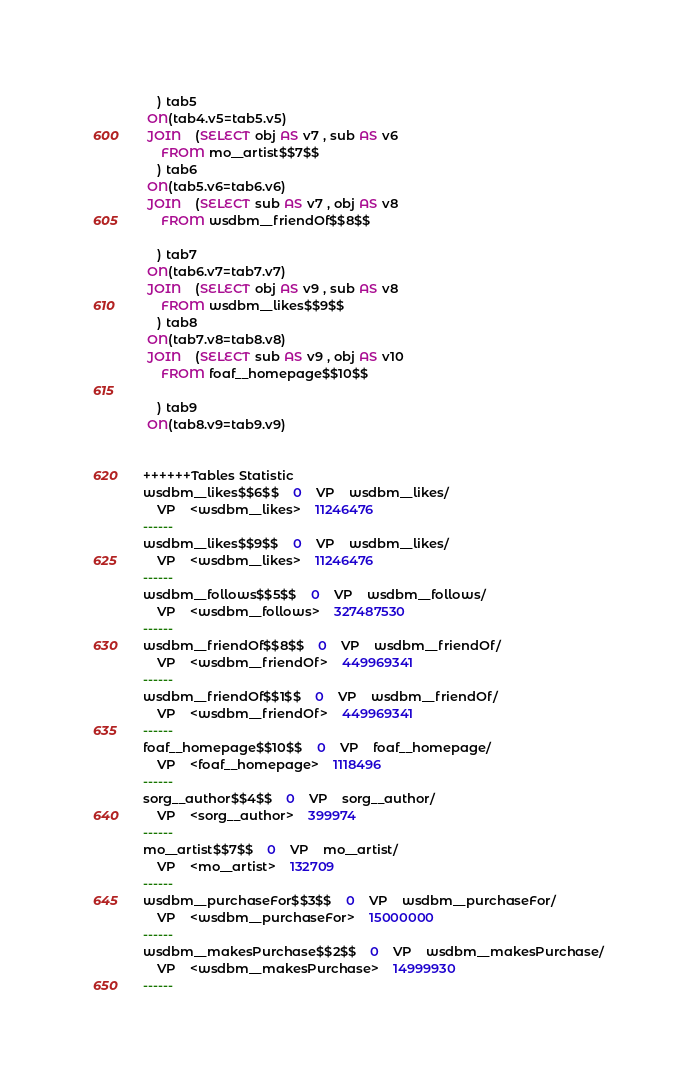Convert code to text. <code><loc_0><loc_0><loc_500><loc_500><_SQL_>	) tab5
 ON(tab4.v5=tab5.v5)
 JOIN    (SELECT obj AS v7 , sub AS v6 
	 FROM mo__artist$$7$$
	) tab6
 ON(tab5.v6=tab6.v6)
 JOIN    (SELECT sub AS v7 , obj AS v8 
	 FROM wsdbm__friendOf$$8$$
	
	) tab7
 ON(tab6.v7=tab7.v7)
 JOIN    (SELECT obj AS v9 , sub AS v8 
	 FROM wsdbm__likes$$9$$
	) tab8
 ON(tab7.v8=tab8.v8)
 JOIN    (SELECT sub AS v9 , obj AS v10 
	 FROM foaf__homepage$$10$$
	
	) tab9
 ON(tab8.v9=tab9.v9)


++++++Tables Statistic
wsdbm__likes$$6$$	0	VP	wsdbm__likes/
	VP	<wsdbm__likes>	11246476
------
wsdbm__likes$$9$$	0	VP	wsdbm__likes/
	VP	<wsdbm__likes>	11246476
------
wsdbm__follows$$5$$	0	VP	wsdbm__follows/
	VP	<wsdbm__follows>	327487530
------
wsdbm__friendOf$$8$$	0	VP	wsdbm__friendOf/
	VP	<wsdbm__friendOf>	449969341
------
wsdbm__friendOf$$1$$	0	VP	wsdbm__friendOf/
	VP	<wsdbm__friendOf>	449969341
------
foaf__homepage$$10$$	0	VP	foaf__homepage/
	VP	<foaf__homepage>	1118496
------
sorg__author$$4$$	0	VP	sorg__author/
	VP	<sorg__author>	399974
------
mo__artist$$7$$	0	VP	mo__artist/
	VP	<mo__artist>	132709
------
wsdbm__purchaseFor$$3$$	0	VP	wsdbm__purchaseFor/
	VP	<wsdbm__purchaseFor>	15000000
------
wsdbm__makesPurchase$$2$$	0	VP	wsdbm__makesPurchase/
	VP	<wsdbm__makesPurchase>	14999930
------
</code> 